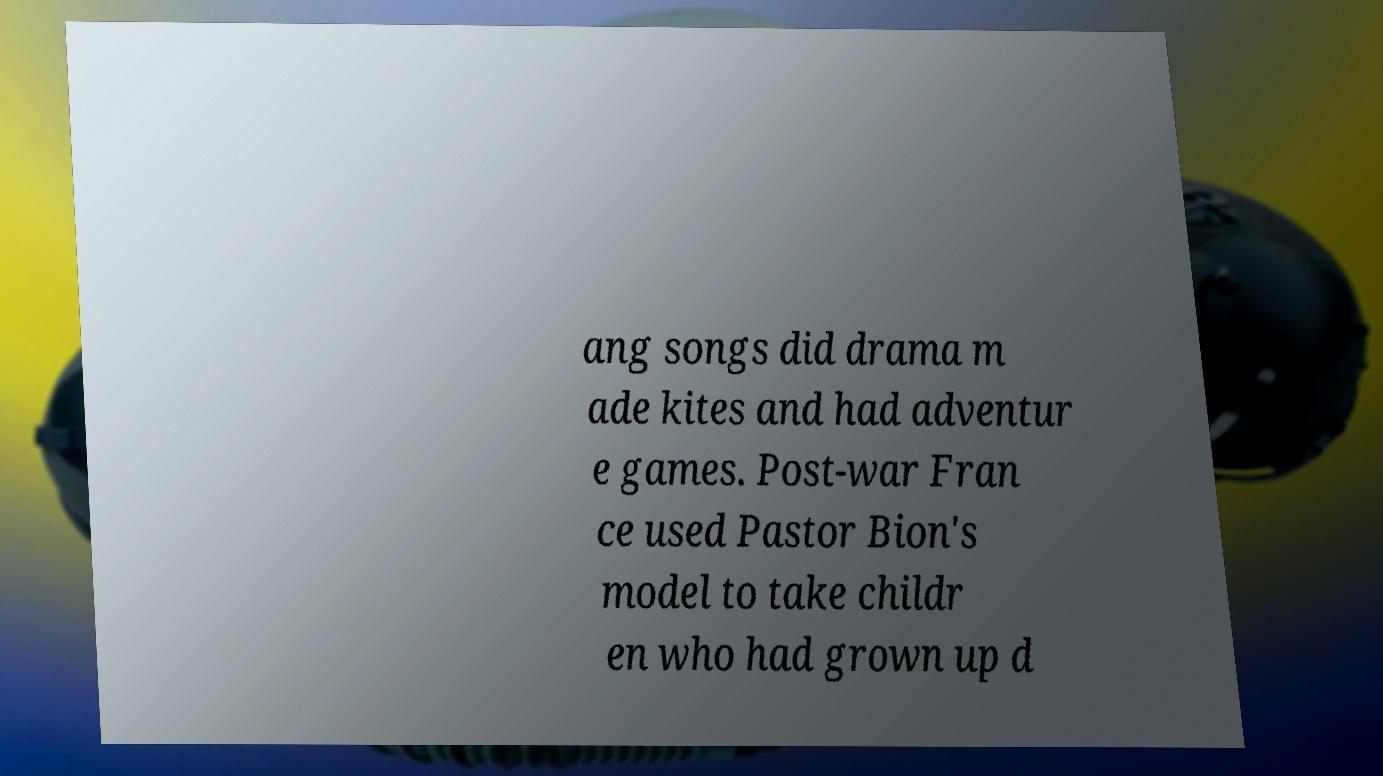What messages or text are displayed in this image? I need them in a readable, typed format. ang songs did drama m ade kites and had adventur e games. Post-war Fran ce used Pastor Bion's model to take childr en who had grown up d 